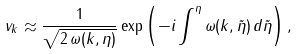<formula> <loc_0><loc_0><loc_500><loc_500>v _ { k } \approx \frac { 1 } { \sqrt { 2 \, \omega ( k , \eta ) } } \exp \left ( - i \int ^ { \eta } \omega ( k , \tilde { \eta } ) \, d \tilde { \eta } \right ) ,</formula> 